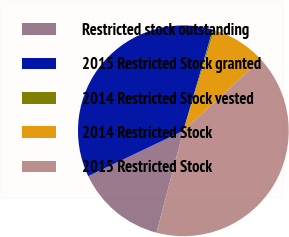Convert chart. <chart><loc_0><loc_0><loc_500><loc_500><pie_chart><fcel>Restricted stock outstanding<fcel>2015 Restricted Stock granted<fcel>2014 Restricted Stock vested<fcel>2014 Restricted Stock<fcel>2015 Restricted Stock<nl><fcel>13.82%<fcel>36.57%<fcel>0.26%<fcel>8.41%<fcel>40.93%<nl></chart> 